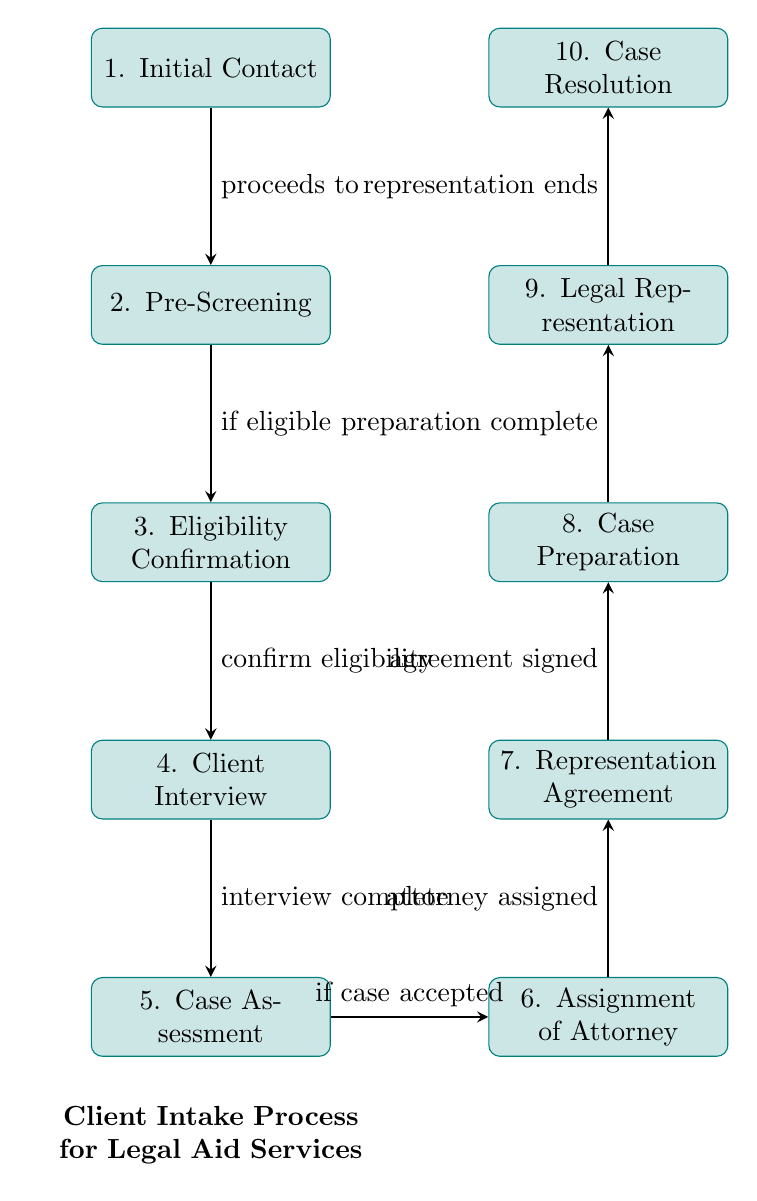What is the first step in the client intake process? The first step indicated in the diagram is "Initial Contact," which is the starting point of the intake process.
Answer: Initial Contact How many steps are there in total in the client intake process? By counting all the listed steps from "Initial Contact" to "Case Resolution," there are a total of 10 steps in the diagram.
Answer: 10 What step follows the "Eligibility Confirmation"? The diagram shows that "Client Interview" directly follows "Eligibility Confirmation."
Answer: Client Interview What is required to proceed from "Pre-Screening" to "Eligibility Confirmation"? According to the diagram, you can only proceed to "Eligibility Confirmation" if the client is "eligible" after the "Pre-Screening" process.
Answer: if eligible What is the step that occurs after the "Case Assessment"? The process indicates that "Assignment of Attorney" is the step that follows "Case Assessment."
Answer: Assignment of Attorney What step comes before signing the "Representation Agreement"? Prior to signing the "Representation Agreement," the step that takes place is "Assignment of Attorney," where the attorney is assigned to the case.
Answer: Assignment of Attorney What is the connection between "Legal Representation" and "Case Resolution"? The diagram illustrates that "Legal Representation" leads to "Case Resolution," marking the end of the representation.
Answer: representation ends What condition must be met to proceed from "Case Assessment" to "Assignment of Attorney"? In order to move from "Case Assessment" to "Assignment of Attorney," it is necessary that the case must be "accepted."
Answer: if case accepted What does the diagram title describe? The title of the diagram describes the "Client Intake Process for Legal Aid Services," summarizing the overall subject of the flowchart.
Answer: Client Intake Process for Legal Aid Services 